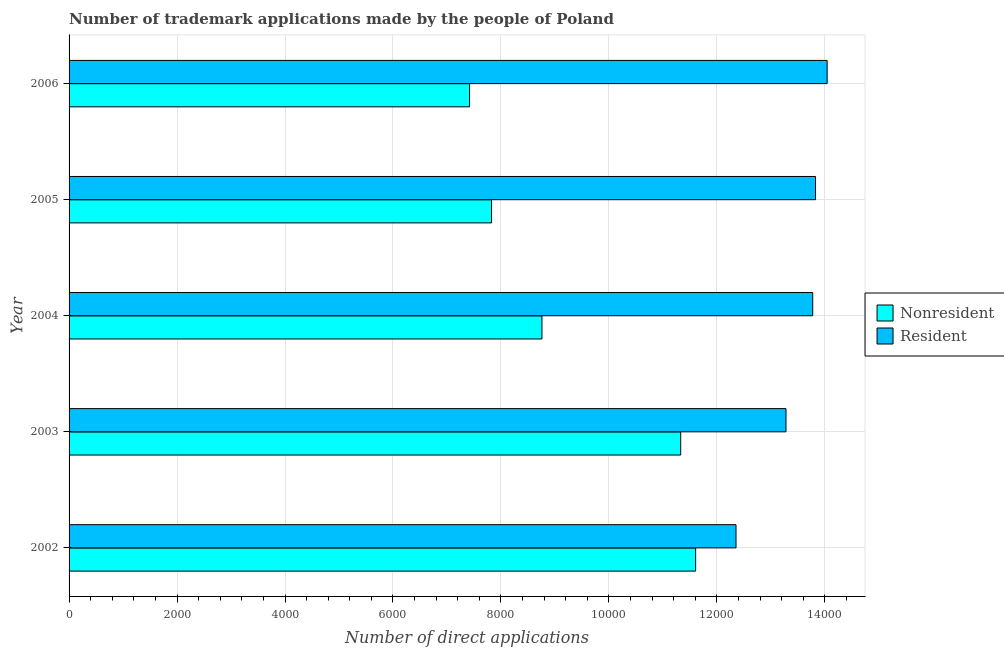Are the number of bars on each tick of the Y-axis equal?
Provide a succinct answer. Yes. How many bars are there on the 4th tick from the bottom?
Make the answer very short. 2. What is the label of the 3rd group of bars from the top?
Give a very brief answer. 2004. What is the number of trademark applications made by non residents in 2004?
Your response must be concise. 8760. Across all years, what is the maximum number of trademark applications made by residents?
Your answer should be very brief. 1.40e+04. Across all years, what is the minimum number of trademark applications made by residents?
Provide a short and direct response. 1.24e+04. In which year was the number of trademark applications made by residents maximum?
Give a very brief answer. 2006. What is the total number of trademark applications made by residents in the graph?
Your response must be concise. 6.73e+04. What is the difference between the number of trademark applications made by non residents in 2003 and that in 2005?
Offer a terse response. 3504. What is the difference between the number of trademark applications made by non residents in 2004 and the number of trademark applications made by residents in 2005?
Keep it short and to the point. -5068. What is the average number of trademark applications made by residents per year?
Make the answer very short. 1.35e+04. In the year 2003, what is the difference between the number of trademark applications made by non residents and number of trademark applications made by residents?
Your answer should be very brief. -1951. What is the ratio of the number of trademark applications made by non residents in 2003 to that in 2004?
Keep it short and to the point. 1.29. Is the number of trademark applications made by residents in 2002 less than that in 2006?
Provide a succinct answer. Yes. Is the difference between the number of trademark applications made by residents in 2004 and 2005 greater than the difference between the number of trademark applications made by non residents in 2004 and 2005?
Make the answer very short. No. What is the difference between the highest and the second highest number of trademark applications made by non residents?
Your answer should be very brief. 277. What is the difference between the highest and the lowest number of trademark applications made by non residents?
Provide a succinct answer. 4188. Is the sum of the number of trademark applications made by residents in 2002 and 2006 greater than the maximum number of trademark applications made by non residents across all years?
Your answer should be compact. Yes. What does the 1st bar from the top in 2005 represents?
Your answer should be very brief. Resident. What does the 2nd bar from the bottom in 2004 represents?
Make the answer very short. Resident. How many bars are there?
Your answer should be very brief. 10. Are all the bars in the graph horizontal?
Give a very brief answer. Yes. What is the difference between two consecutive major ticks on the X-axis?
Your answer should be compact. 2000. Are the values on the major ticks of X-axis written in scientific E-notation?
Make the answer very short. No. Does the graph contain any zero values?
Keep it short and to the point. No. Does the graph contain grids?
Provide a succinct answer. Yes. How many legend labels are there?
Make the answer very short. 2. How are the legend labels stacked?
Ensure brevity in your answer.  Vertical. What is the title of the graph?
Provide a succinct answer. Number of trademark applications made by the people of Poland. Does "Under-5(female)" appear as one of the legend labels in the graph?
Keep it short and to the point. No. What is the label or title of the X-axis?
Keep it short and to the point. Number of direct applications. What is the Number of direct applications of Nonresident in 2002?
Your answer should be compact. 1.16e+04. What is the Number of direct applications of Resident in 2002?
Provide a succinct answer. 1.24e+04. What is the Number of direct applications of Nonresident in 2003?
Your answer should be compact. 1.13e+04. What is the Number of direct applications in Resident in 2003?
Your answer should be very brief. 1.33e+04. What is the Number of direct applications of Nonresident in 2004?
Give a very brief answer. 8760. What is the Number of direct applications of Resident in 2004?
Your answer should be compact. 1.38e+04. What is the Number of direct applications in Nonresident in 2005?
Make the answer very short. 7826. What is the Number of direct applications in Resident in 2005?
Offer a very short reply. 1.38e+04. What is the Number of direct applications of Nonresident in 2006?
Provide a succinct answer. 7419. What is the Number of direct applications of Resident in 2006?
Offer a terse response. 1.40e+04. Across all years, what is the maximum Number of direct applications of Nonresident?
Make the answer very short. 1.16e+04. Across all years, what is the maximum Number of direct applications of Resident?
Your answer should be compact. 1.40e+04. Across all years, what is the minimum Number of direct applications in Nonresident?
Ensure brevity in your answer.  7419. Across all years, what is the minimum Number of direct applications of Resident?
Your answer should be compact. 1.24e+04. What is the total Number of direct applications in Nonresident in the graph?
Your answer should be very brief. 4.69e+04. What is the total Number of direct applications of Resident in the graph?
Provide a succinct answer. 6.73e+04. What is the difference between the Number of direct applications of Nonresident in 2002 and that in 2003?
Your answer should be compact. 277. What is the difference between the Number of direct applications in Resident in 2002 and that in 2003?
Provide a succinct answer. -926. What is the difference between the Number of direct applications of Nonresident in 2002 and that in 2004?
Make the answer very short. 2847. What is the difference between the Number of direct applications in Resident in 2002 and that in 2004?
Your answer should be very brief. -1421. What is the difference between the Number of direct applications in Nonresident in 2002 and that in 2005?
Your response must be concise. 3781. What is the difference between the Number of direct applications of Resident in 2002 and that in 2005?
Your response must be concise. -1473. What is the difference between the Number of direct applications in Nonresident in 2002 and that in 2006?
Provide a succinct answer. 4188. What is the difference between the Number of direct applications in Resident in 2002 and that in 2006?
Give a very brief answer. -1688. What is the difference between the Number of direct applications of Nonresident in 2003 and that in 2004?
Make the answer very short. 2570. What is the difference between the Number of direct applications of Resident in 2003 and that in 2004?
Make the answer very short. -495. What is the difference between the Number of direct applications of Nonresident in 2003 and that in 2005?
Your response must be concise. 3504. What is the difference between the Number of direct applications of Resident in 2003 and that in 2005?
Your answer should be very brief. -547. What is the difference between the Number of direct applications of Nonresident in 2003 and that in 2006?
Your answer should be very brief. 3911. What is the difference between the Number of direct applications of Resident in 2003 and that in 2006?
Make the answer very short. -762. What is the difference between the Number of direct applications of Nonresident in 2004 and that in 2005?
Ensure brevity in your answer.  934. What is the difference between the Number of direct applications of Resident in 2004 and that in 2005?
Make the answer very short. -52. What is the difference between the Number of direct applications of Nonresident in 2004 and that in 2006?
Keep it short and to the point. 1341. What is the difference between the Number of direct applications of Resident in 2004 and that in 2006?
Your answer should be compact. -267. What is the difference between the Number of direct applications in Nonresident in 2005 and that in 2006?
Your answer should be compact. 407. What is the difference between the Number of direct applications of Resident in 2005 and that in 2006?
Provide a succinct answer. -215. What is the difference between the Number of direct applications of Nonresident in 2002 and the Number of direct applications of Resident in 2003?
Provide a succinct answer. -1674. What is the difference between the Number of direct applications of Nonresident in 2002 and the Number of direct applications of Resident in 2004?
Make the answer very short. -2169. What is the difference between the Number of direct applications of Nonresident in 2002 and the Number of direct applications of Resident in 2005?
Keep it short and to the point. -2221. What is the difference between the Number of direct applications of Nonresident in 2002 and the Number of direct applications of Resident in 2006?
Your response must be concise. -2436. What is the difference between the Number of direct applications in Nonresident in 2003 and the Number of direct applications in Resident in 2004?
Provide a short and direct response. -2446. What is the difference between the Number of direct applications of Nonresident in 2003 and the Number of direct applications of Resident in 2005?
Make the answer very short. -2498. What is the difference between the Number of direct applications of Nonresident in 2003 and the Number of direct applications of Resident in 2006?
Offer a very short reply. -2713. What is the difference between the Number of direct applications of Nonresident in 2004 and the Number of direct applications of Resident in 2005?
Your response must be concise. -5068. What is the difference between the Number of direct applications of Nonresident in 2004 and the Number of direct applications of Resident in 2006?
Keep it short and to the point. -5283. What is the difference between the Number of direct applications of Nonresident in 2005 and the Number of direct applications of Resident in 2006?
Your response must be concise. -6217. What is the average Number of direct applications of Nonresident per year?
Provide a short and direct response. 9388.4. What is the average Number of direct applications in Resident per year?
Make the answer very short. 1.35e+04. In the year 2002, what is the difference between the Number of direct applications of Nonresident and Number of direct applications of Resident?
Offer a very short reply. -748. In the year 2003, what is the difference between the Number of direct applications in Nonresident and Number of direct applications in Resident?
Give a very brief answer. -1951. In the year 2004, what is the difference between the Number of direct applications in Nonresident and Number of direct applications in Resident?
Keep it short and to the point. -5016. In the year 2005, what is the difference between the Number of direct applications of Nonresident and Number of direct applications of Resident?
Your response must be concise. -6002. In the year 2006, what is the difference between the Number of direct applications in Nonresident and Number of direct applications in Resident?
Make the answer very short. -6624. What is the ratio of the Number of direct applications of Nonresident in 2002 to that in 2003?
Provide a short and direct response. 1.02. What is the ratio of the Number of direct applications in Resident in 2002 to that in 2003?
Your answer should be very brief. 0.93. What is the ratio of the Number of direct applications in Nonresident in 2002 to that in 2004?
Your answer should be very brief. 1.32. What is the ratio of the Number of direct applications of Resident in 2002 to that in 2004?
Ensure brevity in your answer.  0.9. What is the ratio of the Number of direct applications in Nonresident in 2002 to that in 2005?
Provide a short and direct response. 1.48. What is the ratio of the Number of direct applications of Resident in 2002 to that in 2005?
Ensure brevity in your answer.  0.89. What is the ratio of the Number of direct applications in Nonresident in 2002 to that in 2006?
Provide a short and direct response. 1.56. What is the ratio of the Number of direct applications of Resident in 2002 to that in 2006?
Provide a short and direct response. 0.88. What is the ratio of the Number of direct applications of Nonresident in 2003 to that in 2004?
Give a very brief answer. 1.29. What is the ratio of the Number of direct applications in Resident in 2003 to that in 2004?
Offer a terse response. 0.96. What is the ratio of the Number of direct applications of Nonresident in 2003 to that in 2005?
Give a very brief answer. 1.45. What is the ratio of the Number of direct applications in Resident in 2003 to that in 2005?
Your answer should be compact. 0.96. What is the ratio of the Number of direct applications of Nonresident in 2003 to that in 2006?
Provide a succinct answer. 1.53. What is the ratio of the Number of direct applications in Resident in 2003 to that in 2006?
Give a very brief answer. 0.95. What is the ratio of the Number of direct applications of Nonresident in 2004 to that in 2005?
Keep it short and to the point. 1.12. What is the ratio of the Number of direct applications of Nonresident in 2004 to that in 2006?
Your answer should be compact. 1.18. What is the ratio of the Number of direct applications of Resident in 2004 to that in 2006?
Make the answer very short. 0.98. What is the ratio of the Number of direct applications of Nonresident in 2005 to that in 2006?
Provide a short and direct response. 1.05. What is the ratio of the Number of direct applications in Resident in 2005 to that in 2006?
Keep it short and to the point. 0.98. What is the difference between the highest and the second highest Number of direct applications of Nonresident?
Offer a terse response. 277. What is the difference between the highest and the second highest Number of direct applications in Resident?
Provide a short and direct response. 215. What is the difference between the highest and the lowest Number of direct applications of Nonresident?
Provide a short and direct response. 4188. What is the difference between the highest and the lowest Number of direct applications in Resident?
Ensure brevity in your answer.  1688. 